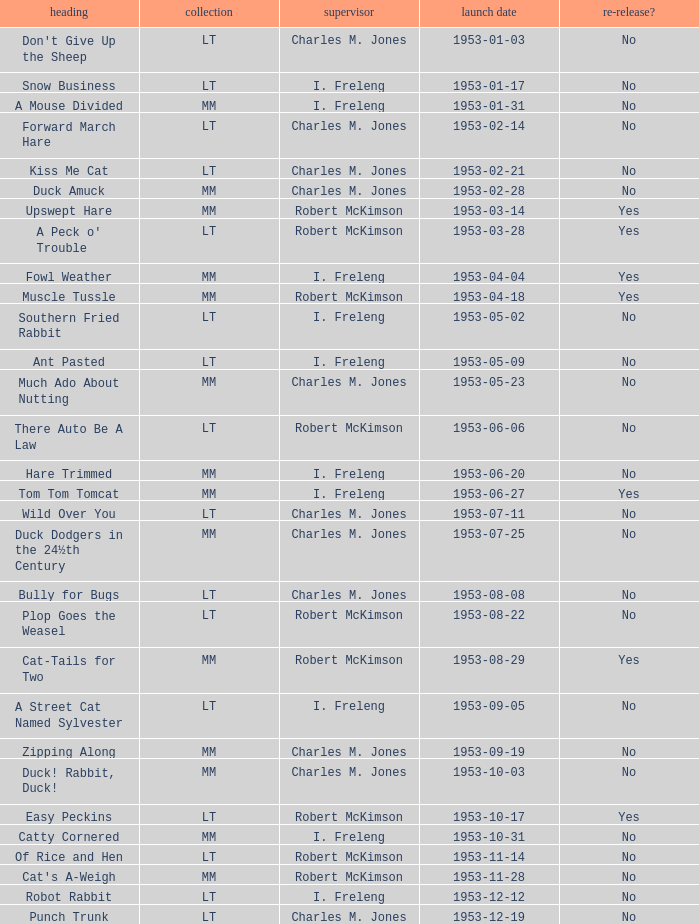Was there a reissue of the film released on 1953-10-03? No. 